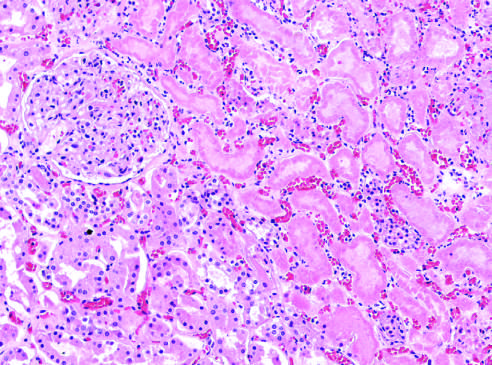re the preserved outlines with loss of nuclei?
Answer the question using a single word or phrase. Yes 